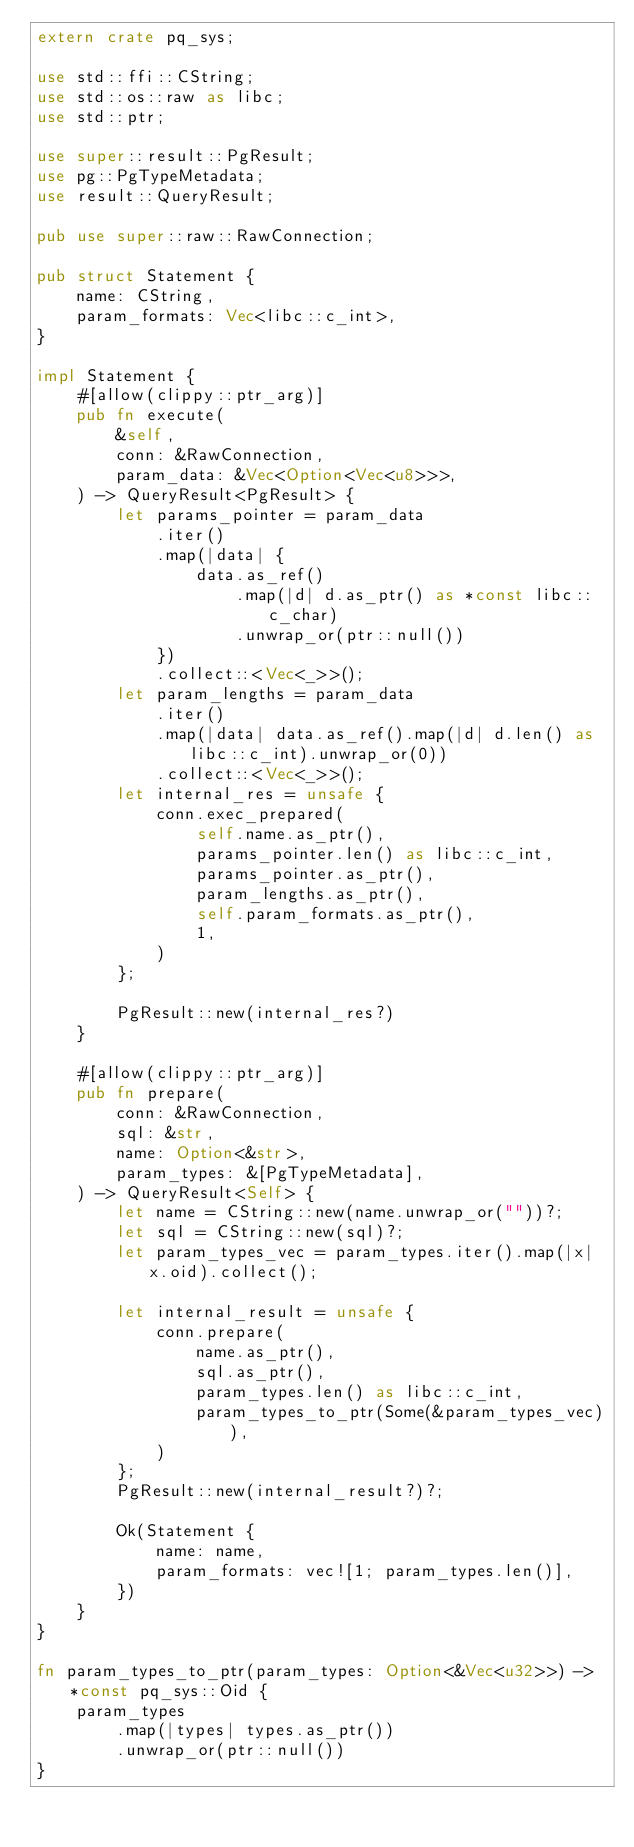Convert code to text. <code><loc_0><loc_0><loc_500><loc_500><_Rust_>extern crate pq_sys;

use std::ffi::CString;
use std::os::raw as libc;
use std::ptr;

use super::result::PgResult;
use pg::PgTypeMetadata;
use result::QueryResult;

pub use super::raw::RawConnection;

pub struct Statement {
    name: CString,
    param_formats: Vec<libc::c_int>,
}

impl Statement {
    #[allow(clippy::ptr_arg)]
    pub fn execute(
        &self,
        conn: &RawConnection,
        param_data: &Vec<Option<Vec<u8>>>,
    ) -> QueryResult<PgResult> {
        let params_pointer = param_data
            .iter()
            .map(|data| {
                data.as_ref()
                    .map(|d| d.as_ptr() as *const libc::c_char)
                    .unwrap_or(ptr::null())
            })
            .collect::<Vec<_>>();
        let param_lengths = param_data
            .iter()
            .map(|data| data.as_ref().map(|d| d.len() as libc::c_int).unwrap_or(0))
            .collect::<Vec<_>>();
        let internal_res = unsafe {
            conn.exec_prepared(
                self.name.as_ptr(),
                params_pointer.len() as libc::c_int,
                params_pointer.as_ptr(),
                param_lengths.as_ptr(),
                self.param_formats.as_ptr(),
                1,
            )
        };

        PgResult::new(internal_res?)
    }

    #[allow(clippy::ptr_arg)]
    pub fn prepare(
        conn: &RawConnection,
        sql: &str,
        name: Option<&str>,
        param_types: &[PgTypeMetadata],
    ) -> QueryResult<Self> {
        let name = CString::new(name.unwrap_or(""))?;
        let sql = CString::new(sql)?;
        let param_types_vec = param_types.iter().map(|x| x.oid).collect();

        let internal_result = unsafe {
            conn.prepare(
                name.as_ptr(),
                sql.as_ptr(),
                param_types.len() as libc::c_int,
                param_types_to_ptr(Some(&param_types_vec)),
            )
        };
        PgResult::new(internal_result?)?;

        Ok(Statement {
            name: name,
            param_formats: vec![1; param_types.len()],
        })
    }
}

fn param_types_to_ptr(param_types: Option<&Vec<u32>>) -> *const pq_sys::Oid {
    param_types
        .map(|types| types.as_ptr())
        .unwrap_or(ptr::null())
}
</code> 